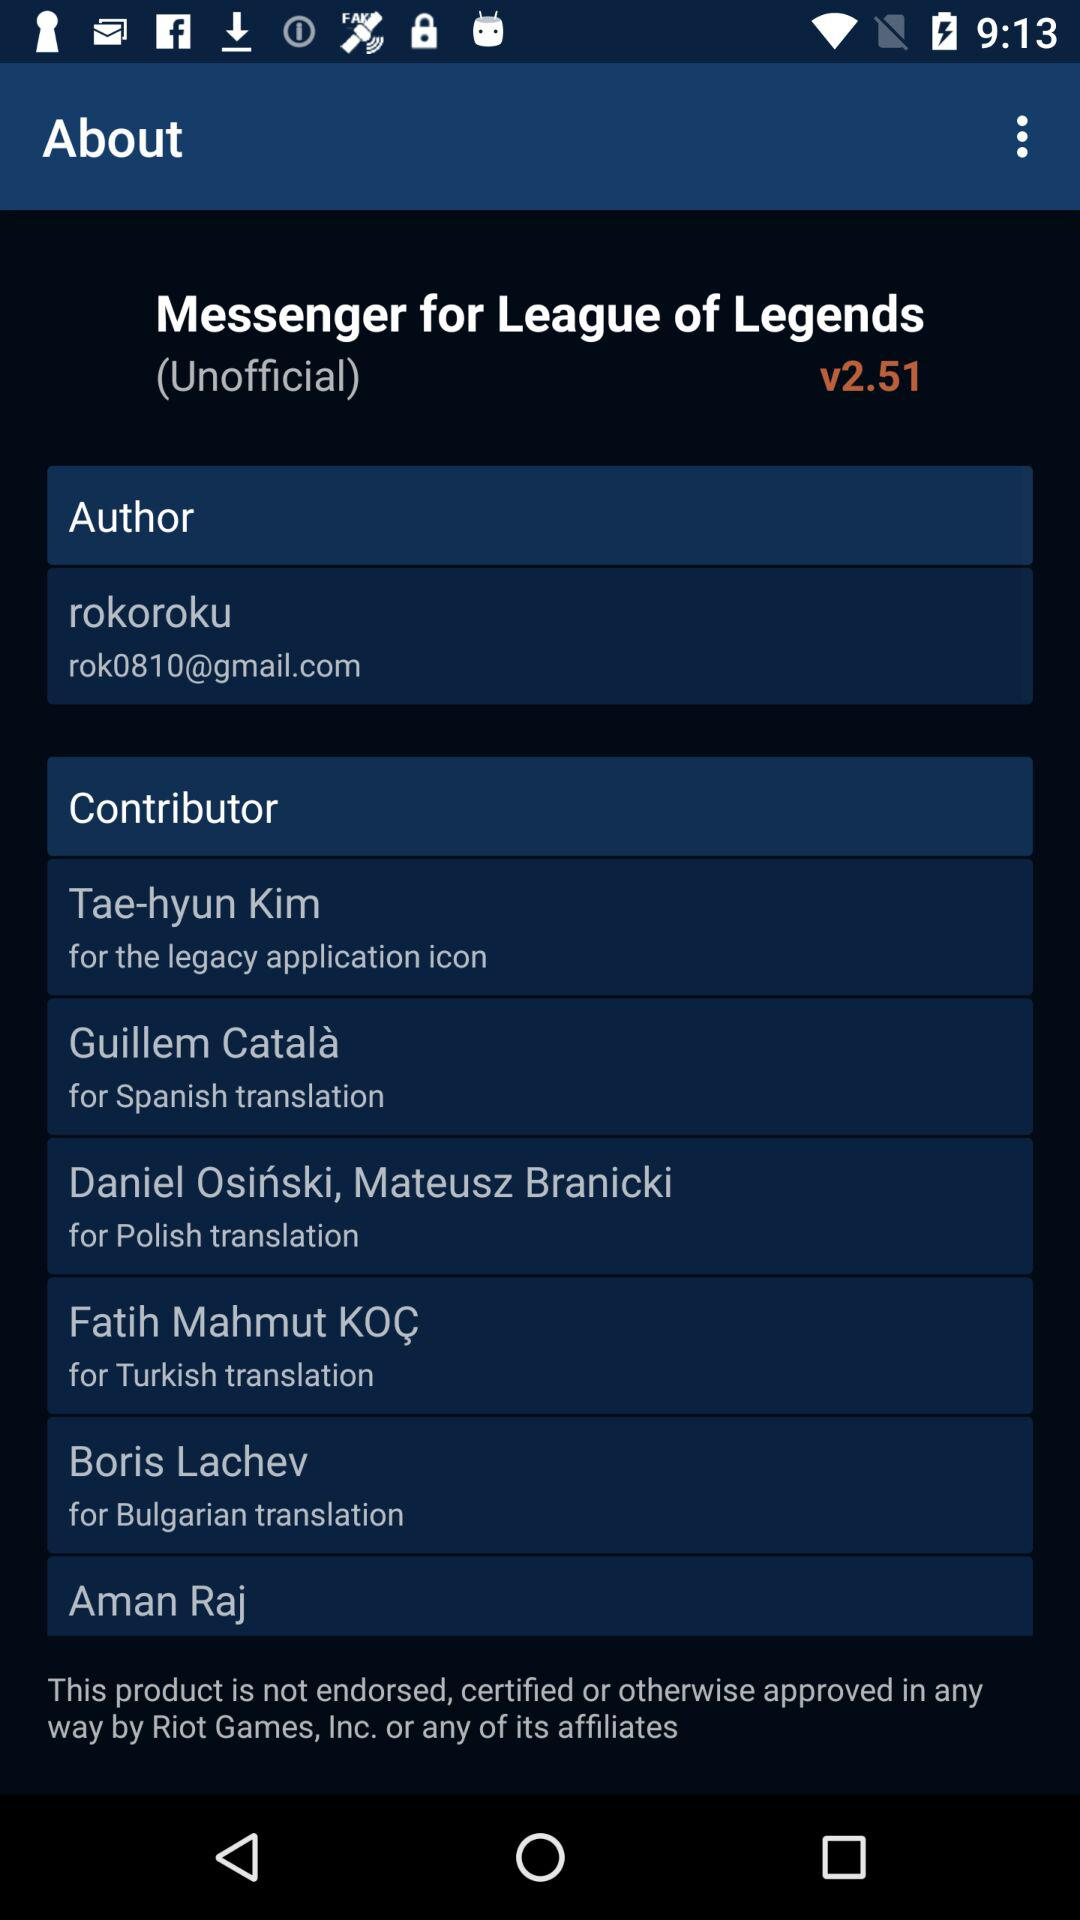Who is the contributor for the Polish translation? The contributors are Daniel Osiński and Mateusz Branicki. 